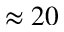Convert formula to latex. <formula><loc_0><loc_0><loc_500><loc_500>\approx 2 0</formula> 